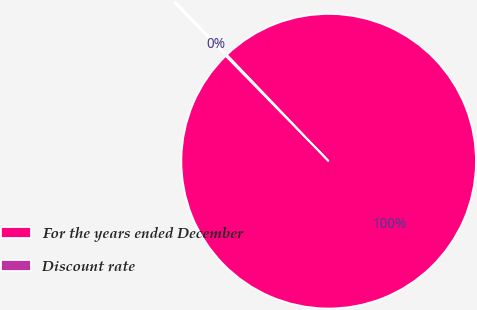Convert chart to OTSL. <chart><loc_0><loc_0><loc_500><loc_500><pie_chart><fcel>For the years ended December<fcel>Discount rate<nl><fcel>99.82%<fcel>0.18%<nl></chart> 